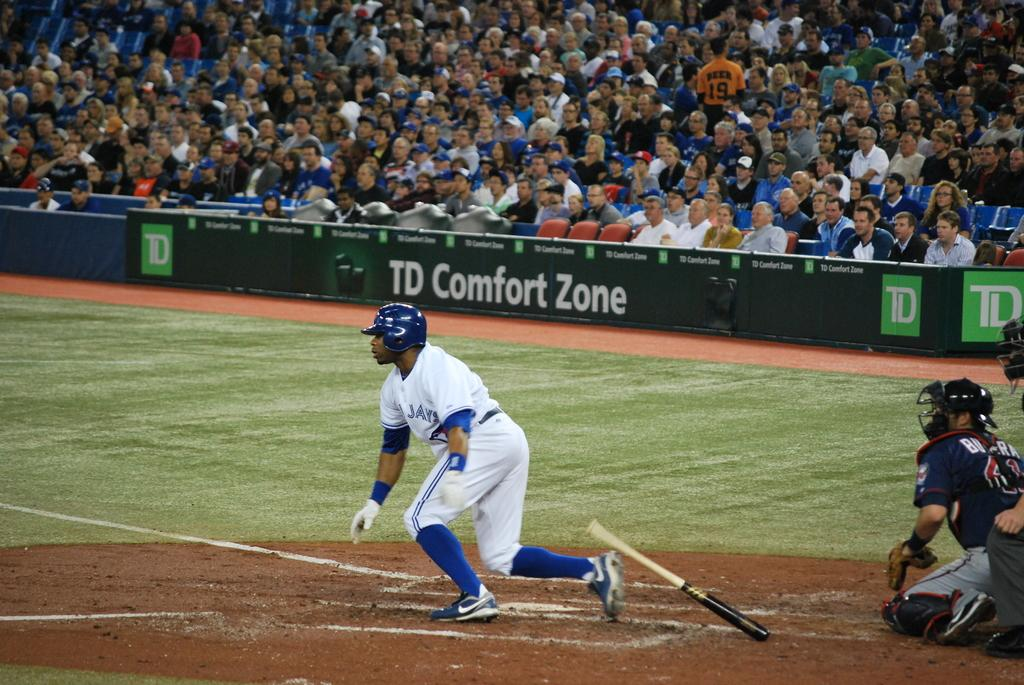<image>
Present a compact description of the photo's key features. A Blue Jays player throws his bat on the ground as he gets ready to run to first base. 